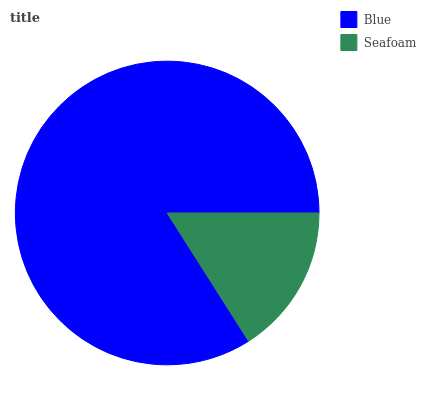Is Seafoam the minimum?
Answer yes or no. Yes. Is Blue the maximum?
Answer yes or no. Yes. Is Seafoam the maximum?
Answer yes or no. No. Is Blue greater than Seafoam?
Answer yes or no. Yes. Is Seafoam less than Blue?
Answer yes or no. Yes. Is Seafoam greater than Blue?
Answer yes or no. No. Is Blue less than Seafoam?
Answer yes or no. No. Is Blue the high median?
Answer yes or no. Yes. Is Seafoam the low median?
Answer yes or no. Yes. Is Seafoam the high median?
Answer yes or no. No. Is Blue the low median?
Answer yes or no. No. 